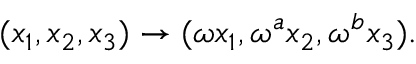<formula> <loc_0><loc_0><loc_500><loc_500>( x _ { 1 } , x _ { 2 } , x _ { 3 } ) \rightarrow ( \omega x _ { 1 } , \omega ^ { a } x _ { 2 } , \omega ^ { b } x _ { 3 } ) .</formula> 